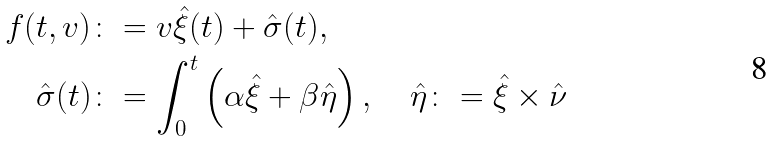Convert formula to latex. <formula><loc_0><loc_0><loc_500><loc_500>f ( t , v ) & \colon = v \hat { \xi } ( t ) + \hat { \sigma } ( t ) , \\ \hat { \sigma } ( t ) & \colon = \int _ { 0 } ^ { t } \left ( \alpha \hat { \xi } + \beta \hat { \eta } \right ) , \quad \hat { \eta } \colon = \hat { \xi } \times \hat { \nu }</formula> 